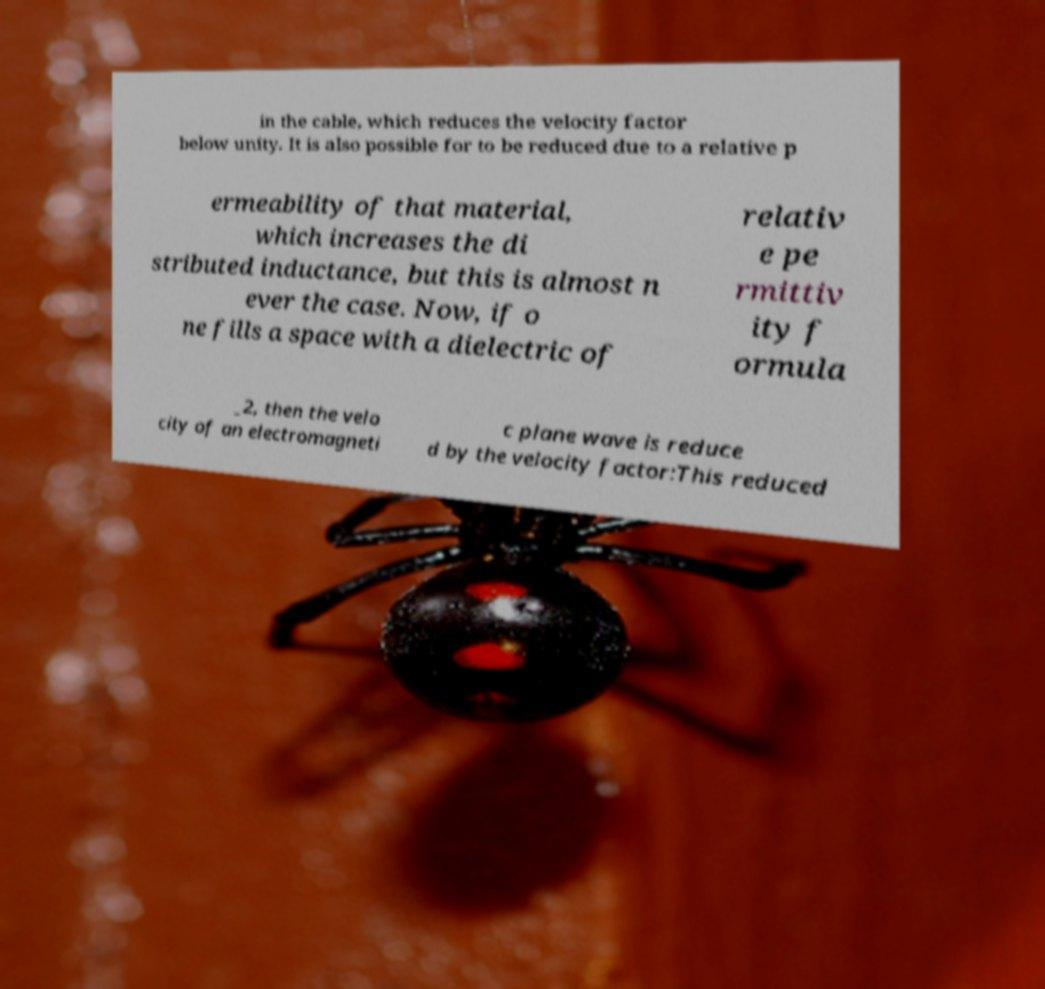Can you read and provide the text displayed in the image?This photo seems to have some interesting text. Can you extract and type it out for me? in the cable, which reduces the velocity factor below unity. It is also possible for to be reduced due to a relative p ermeability of that material, which increases the di stributed inductance, but this is almost n ever the case. Now, if o ne fills a space with a dielectric of relativ e pe rmittiv ity f ormula _2, then the velo city of an electromagneti c plane wave is reduce d by the velocity factor:This reduced 